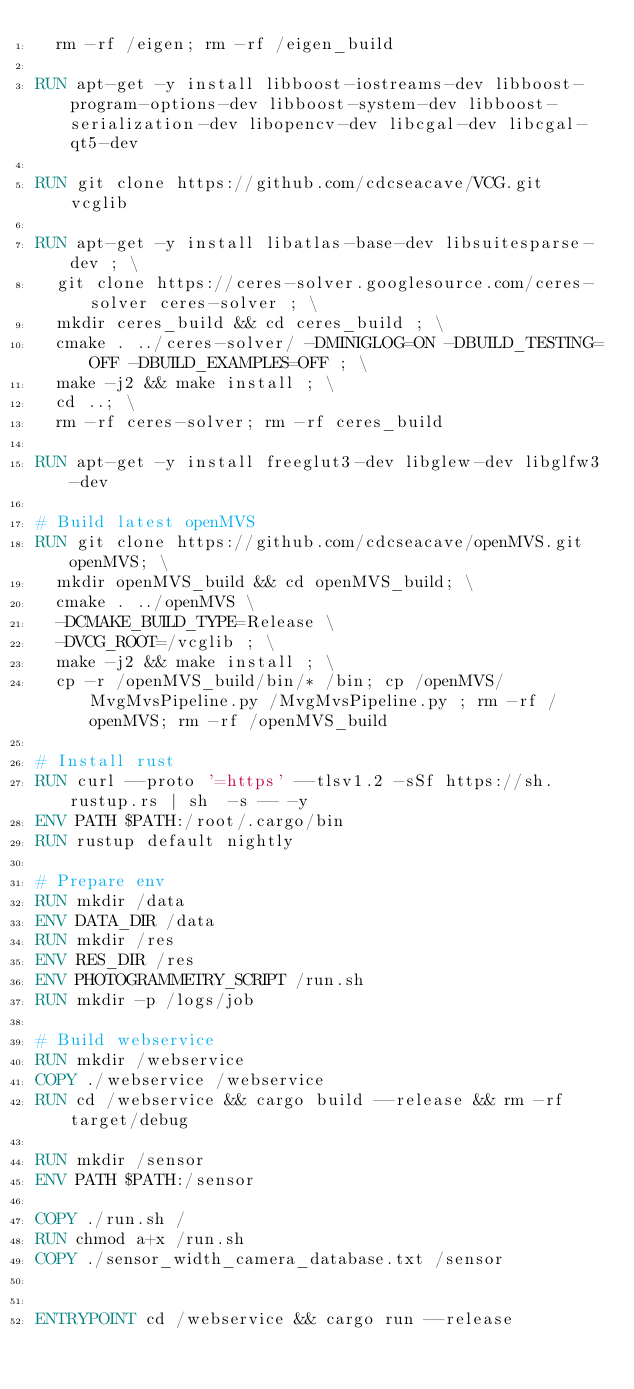Convert code to text. <code><loc_0><loc_0><loc_500><loc_500><_Dockerfile_>  rm -rf /eigen; rm -rf /eigen_build

RUN apt-get -y install libboost-iostreams-dev libboost-program-options-dev libboost-system-dev libboost-serialization-dev libopencv-dev libcgal-dev libcgal-qt5-dev

RUN git clone https://github.com/cdcseacave/VCG.git vcglib

RUN apt-get -y install libatlas-base-dev libsuitesparse-dev ; \
  git clone https://ceres-solver.googlesource.com/ceres-solver ceres-solver ; \
  mkdir ceres_build && cd ceres_build ; \
  cmake . ../ceres-solver/ -DMINIGLOG=ON -DBUILD_TESTING=OFF -DBUILD_EXAMPLES=OFF ; \
  make -j2 && make install ; \
  cd ..; \
  rm -rf ceres-solver; rm -rf ceres_build

RUN apt-get -y install freeglut3-dev libglew-dev libglfw3-dev

# Build latest openMVS
RUN git clone https://github.com/cdcseacave/openMVS.git openMVS; \
  mkdir openMVS_build && cd openMVS_build; \
  cmake . ../openMVS \
  -DCMAKE_BUILD_TYPE=Release \
  -DVCG_ROOT=/vcglib ; \
  make -j2 && make install ; \
  cp -r /openMVS_build/bin/* /bin; cp /openMVS/MvgMvsPipeline.py /MvgMvsPipeline.py ; rm -rf /openMVS; rm -rf /openMVS_build

# Install rust
RUN curl --proto '=https' --tlsv1.2 -sSf https://sh.rustup.rs | sh  -s -- -y
ENV PATH $PATH:/root/.cargo/bin
RUN rustup default nightly

# Prepare env
RUN mkdir /data
ENV DATA_DIR /data
RUN mkdir /res
ENV RES_DIR /res
ENV PHOTOGRAMMETRY_SCRIPT /run.sh
RUN mkdir -p /logs/job

# Build webservice
RUN mkdir /webservice
COPY ./webservice /webservice
RUN cd /webservice && cargo build --release && rm -rf target/debug

RUN mkdir /sensor
ENV PATH $PATH:/sensor

COPY ./run.sh /
RUN chmod a+x /run.sh
COPY ./sensor_width_camera_database.txt /sensor


ENTRYPOINT cd /webservice && cargo run --release
</code> 